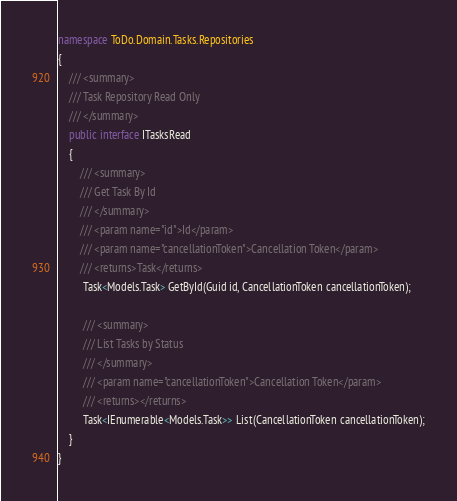Convert code to text. <code><loc_0><loc_0><loc_500><loc_500><_C#_>namespace ToDo.Domain.Tasks.Repositories
{
    /// <summary>
    /// Task Repository Read Only
    /// </summary>
    public interface ITasksRead
    {
        /// <summary>
        /// Get Task By Id
        /// </summary>
        /// <param name="id">Id</param>
        /// <param name="cancellationToken">Cancellation Token</param>
        /// <returns>Task</returns>
         Task<Models.Task> GetById(Guid id, CancellationToken cancellationToken);
         
         /// <summary>
         /// List Tasks by Status
         /// </summary>
         /// <param name="cancellationToken">Cancellation Token</param>
         /// <returns></returns>
         Task<IEnumerable<Models.Task>> List(CancellationToken cancellationToken);
    }
}</code> 